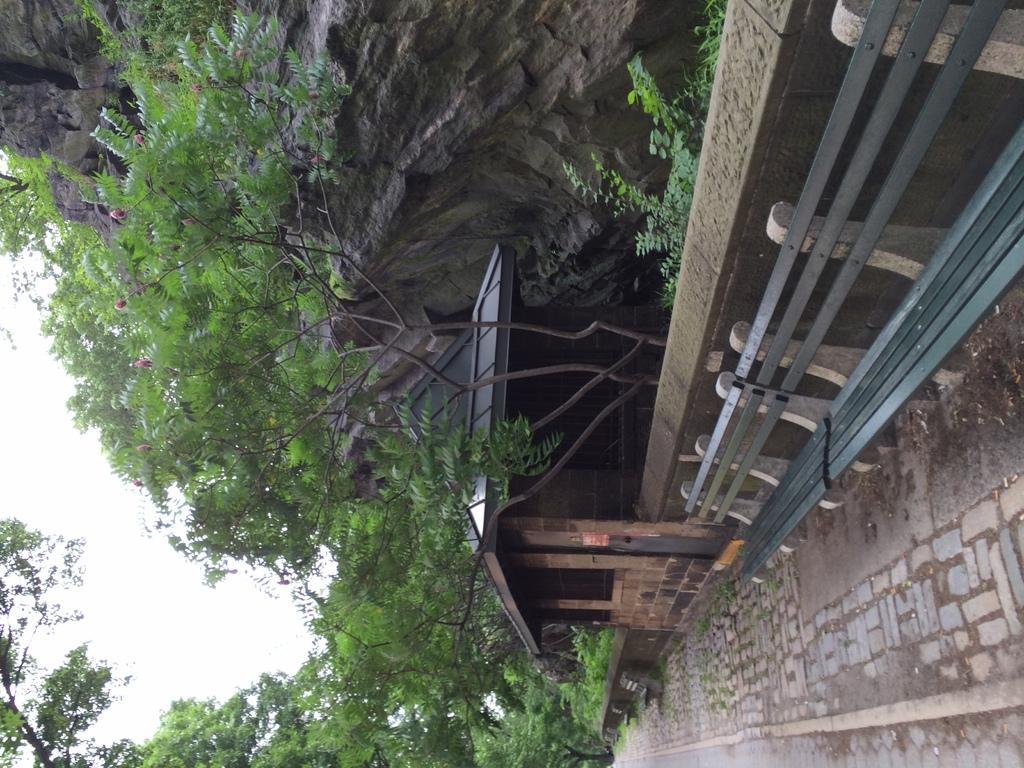What type of seating is available on the path in the image? There are benches on the path in the image. What is located behind the benches? There is a wall behind the benches. What can be seen behind the wall? There are trees behind the wall. What is the landscape feature behind the trees? There is a hill behind the trees. What is visible in the background of the image? The sky is visible behind the hill. How do the geese feel about running on the hill in the image? There are no geese present in the image, so it is not possible to determine their feelings or actions. 